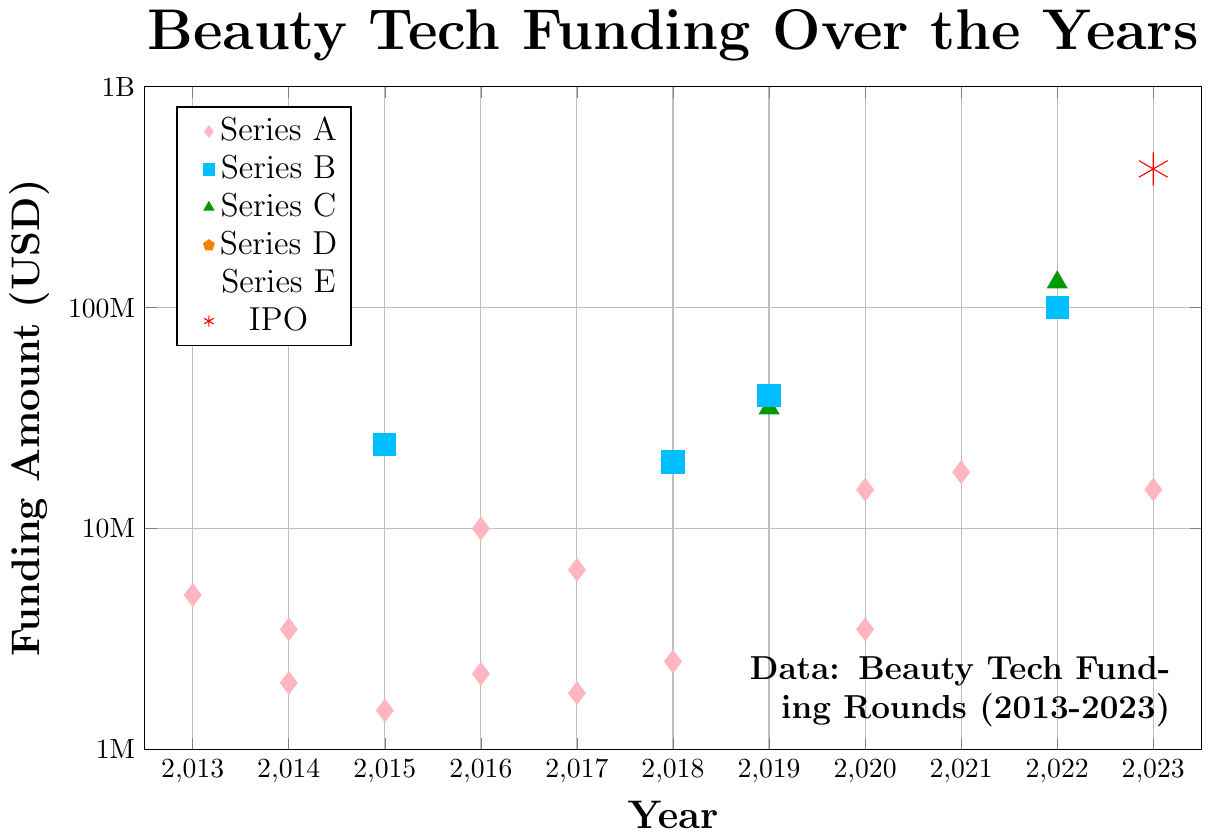which funding round has the highest amount? First, observe that different symbol shapes represent different funding rounds. The largest red asterisk at the top represents the highest funding amount. According to the legend, the red asterisk corresponds to an IPO, which received $424,000,000.
Answer: IPO What are the years with the highest seed funding? Look for symbols with Series A label near the top of the y-axis. The years with high position symbols for Series A are checked. The highest value among Seed is the one in 2022.
Answer: 2022 How many Series B funding rounds have there been? Count the number of symbols marked with a blue square, which represents Series B in the legend. There are three blue squares visible.
Answer: 3 Which company received the highest Series C funding? Identify the green triangles which represent Series C funding. The highest green triangle corresponds to the company in the year 2022.
Answer: Il Makiage Compare seed funding amounts in 2017 to 2018. Which year has a higher amount? Locate the pink diamond symbols for Seed funding in 2017 and 2018. Compare their positions on the y-axis. The 2018 diamond is higher on the y-axis than the one in 2017.
Answer: 2018 Which year has the majority of Series E funding? Look at the symbols marked with a purple star, which symbolize Series E. There is only one purple star and it is in 2021.
Answer: 2021 What is the total Series A funding in 2020? Find the pink diamond symbols for Series A in 2020. There are two of them: 15,000,000 and 3,500,000. The sum of these amounts equals 18,500,000.
Answer: 18,500,000 Which year saw the lowest Series A funding and how much was it? Locate the pink diamond symbols for Series A, then find the one lowest on the y-axis. This symbol appears in 2014 and its amount is 2,000,000.
Answer: 2014, 2,000,000 Which funding round has more variety in funding amounts, Series B or Series C? Identify the squares (Series B) and triangles (Series C). Series B appears to have funding amounts of 200,000,00, 40,000,00, and 100,000,000, while Series C has 35,000,000 and 130,000,000.
Answer: Series B 